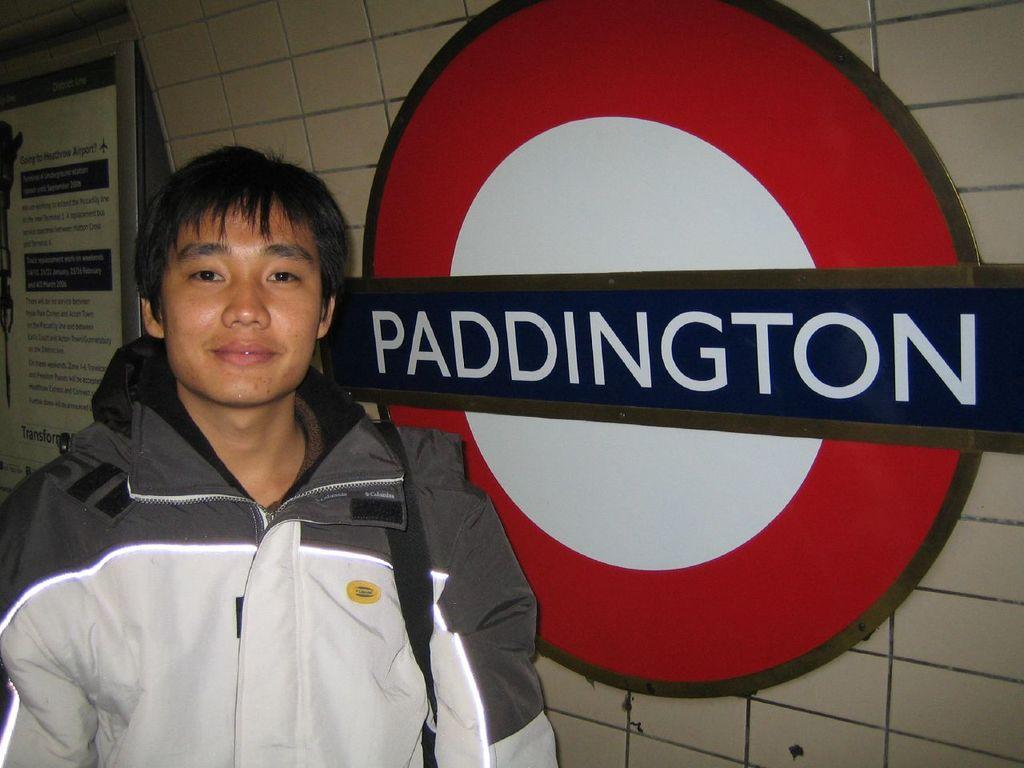Provide a one-sentence caption for the provided image. A young man standing next to the Paddington train station sign having his picture taken. 